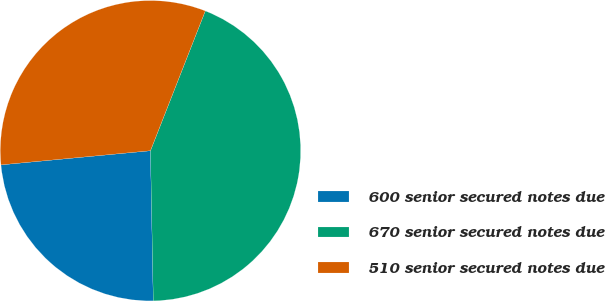Convert chart. <chart><loc_0><loc_0><loc_500><loc_500><pie_chart><fcel>600 senior secured notes due<fcel>670 senior secured notes due<fcel>510 senior secured notes due<nl><fcel>23.8%<fcel>43.75%<fcel>32.45%<nl></chart> 